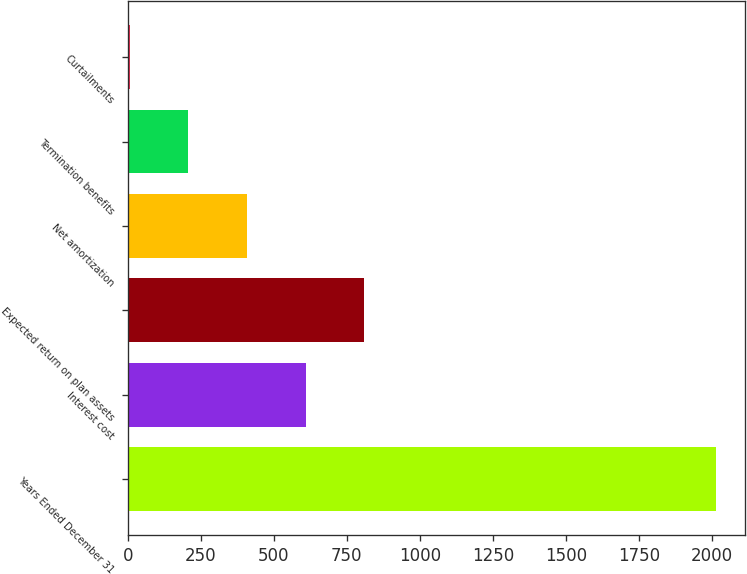Convert chart to OTSL. <chart><loc_0><loc_0><loc_500><loc_500><bar_chart><fcel>Years Ended December 31<fcel>Interest cost<fcel>Expected return on plan assets<fcel>Net amortization<fcel>Termination benefits<fcel>Curtailments<nl><fcel>2012<fcel>608.5<fcel>809<fcel>408<fcel>207.5<fcel>7<nl></chart> 